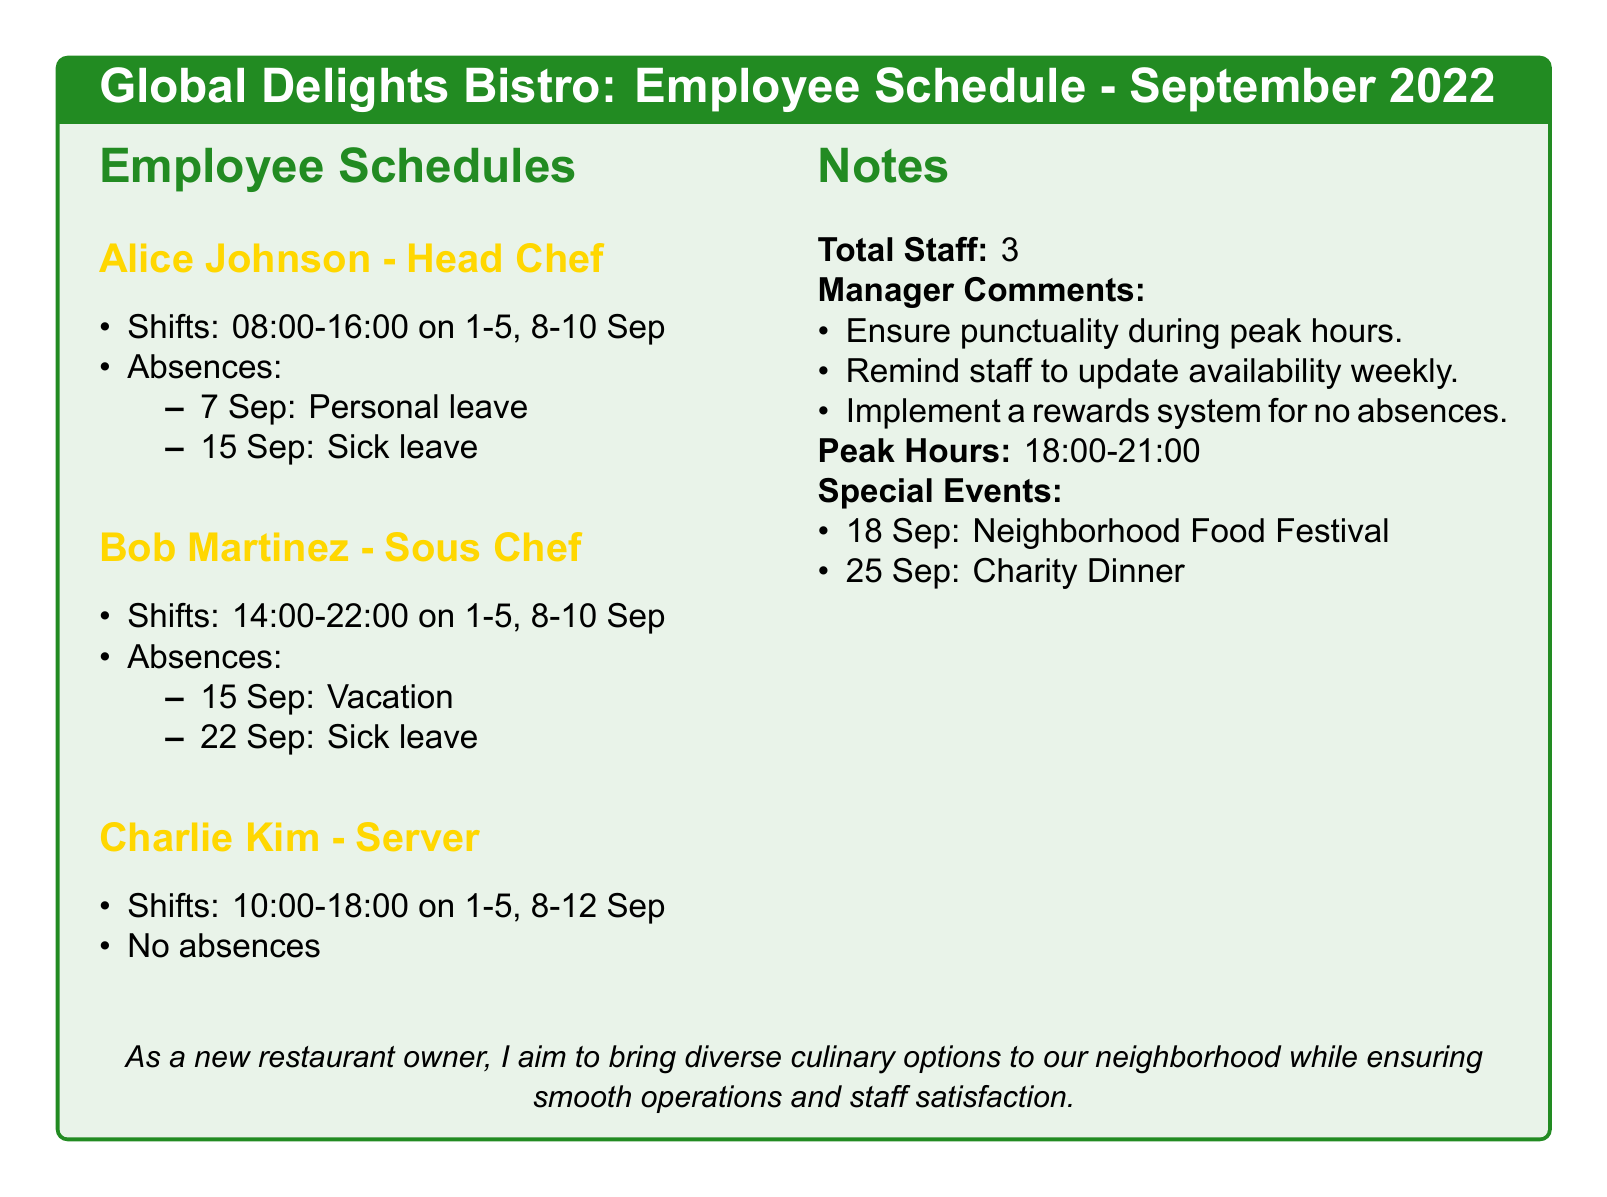What is the name of the head chef? The head chef's name is mentioned in the employee schedule section.
Answer: Alice Johnson How many staff members are listed? The total number of staff is explicitly stated in the notes section of the document.
Answer: 3 What is the shift time for Bob Martinez? The shift time for Bob Martinez can be found in his schedule listing.
Answer: 14:00-22:00 On what date did Alice Johnson take personal leave? The absence dates for Alice Johnson are included in the schedule section.
Answer: 7 Sep What is the peak hour for the restaurant? The peak hours are specifically highlighted in the notes section.
Answer: 18:00-21:00 What event is scheduled for 25 September? The special events section lists the events along with their dates.
Answer: Charity Dinner Who did not have any absences? The server's name is detailed in the employee schedules, noting absence status.
Answer: Charlie Kim What is a suggestion given by the manager? The manager comments include several recommendations for staff management.
Answer: Ensure punctuality during peak hours 